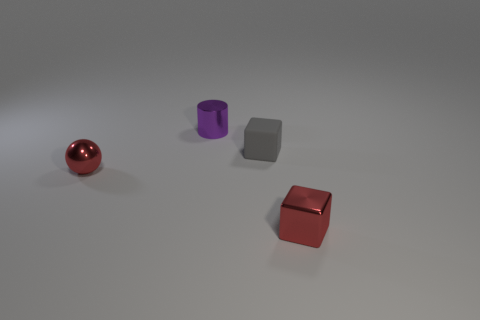Is the number of red metallic balls in front of the gray rubber thing greater than the number of large red cylinders?
Make the answer very short. Yes. There is a block that is left of the metallic thing that is to the right of the matte thing; what number of red objects are left of it?
Provide a succinct answer. 1. What is the material of the thing that is to the right of the purple metal object and left of the metal cube?
Your response must be concise. Rubber. The cylinder is what color?
Make the answer very short. Purple. Are there more tiny metallic things that are on the left side of the shiny cylinder than red metal objects behind the small red ball?
Give a very brief answer. Yes. What color is the rubber thing that is behind the red sphere?
Your answer should be compact. Gray. What number of things are either red blocks or small cylinders?
Keep it short and to the point. 2. There is a tiny block that is behind the tiny red metallic object that is on the left side of the small gray object; what is its material?
Your answer should be very brief. Rubber. How many other small rubber things are the same shape as the gray object?
Make the answer very short. 0. Is there a tiny shiny block of the same color as the metal sphere?
Provide a short and direct response. Yes. 